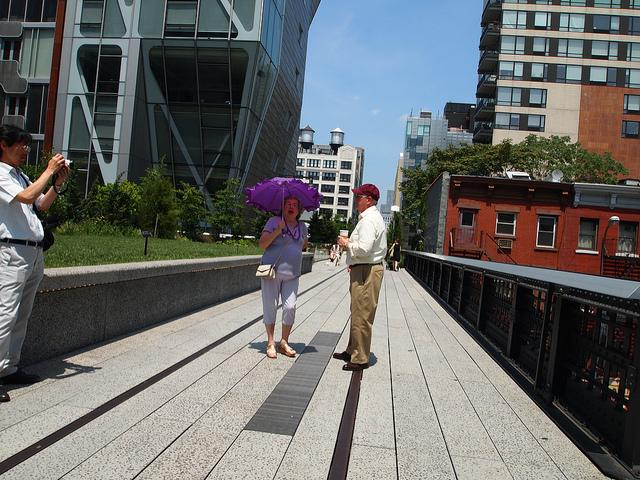The tanks seen in the background above the building once held what?

Choices:
A) butane
B) oil
C) propane
D) water water 